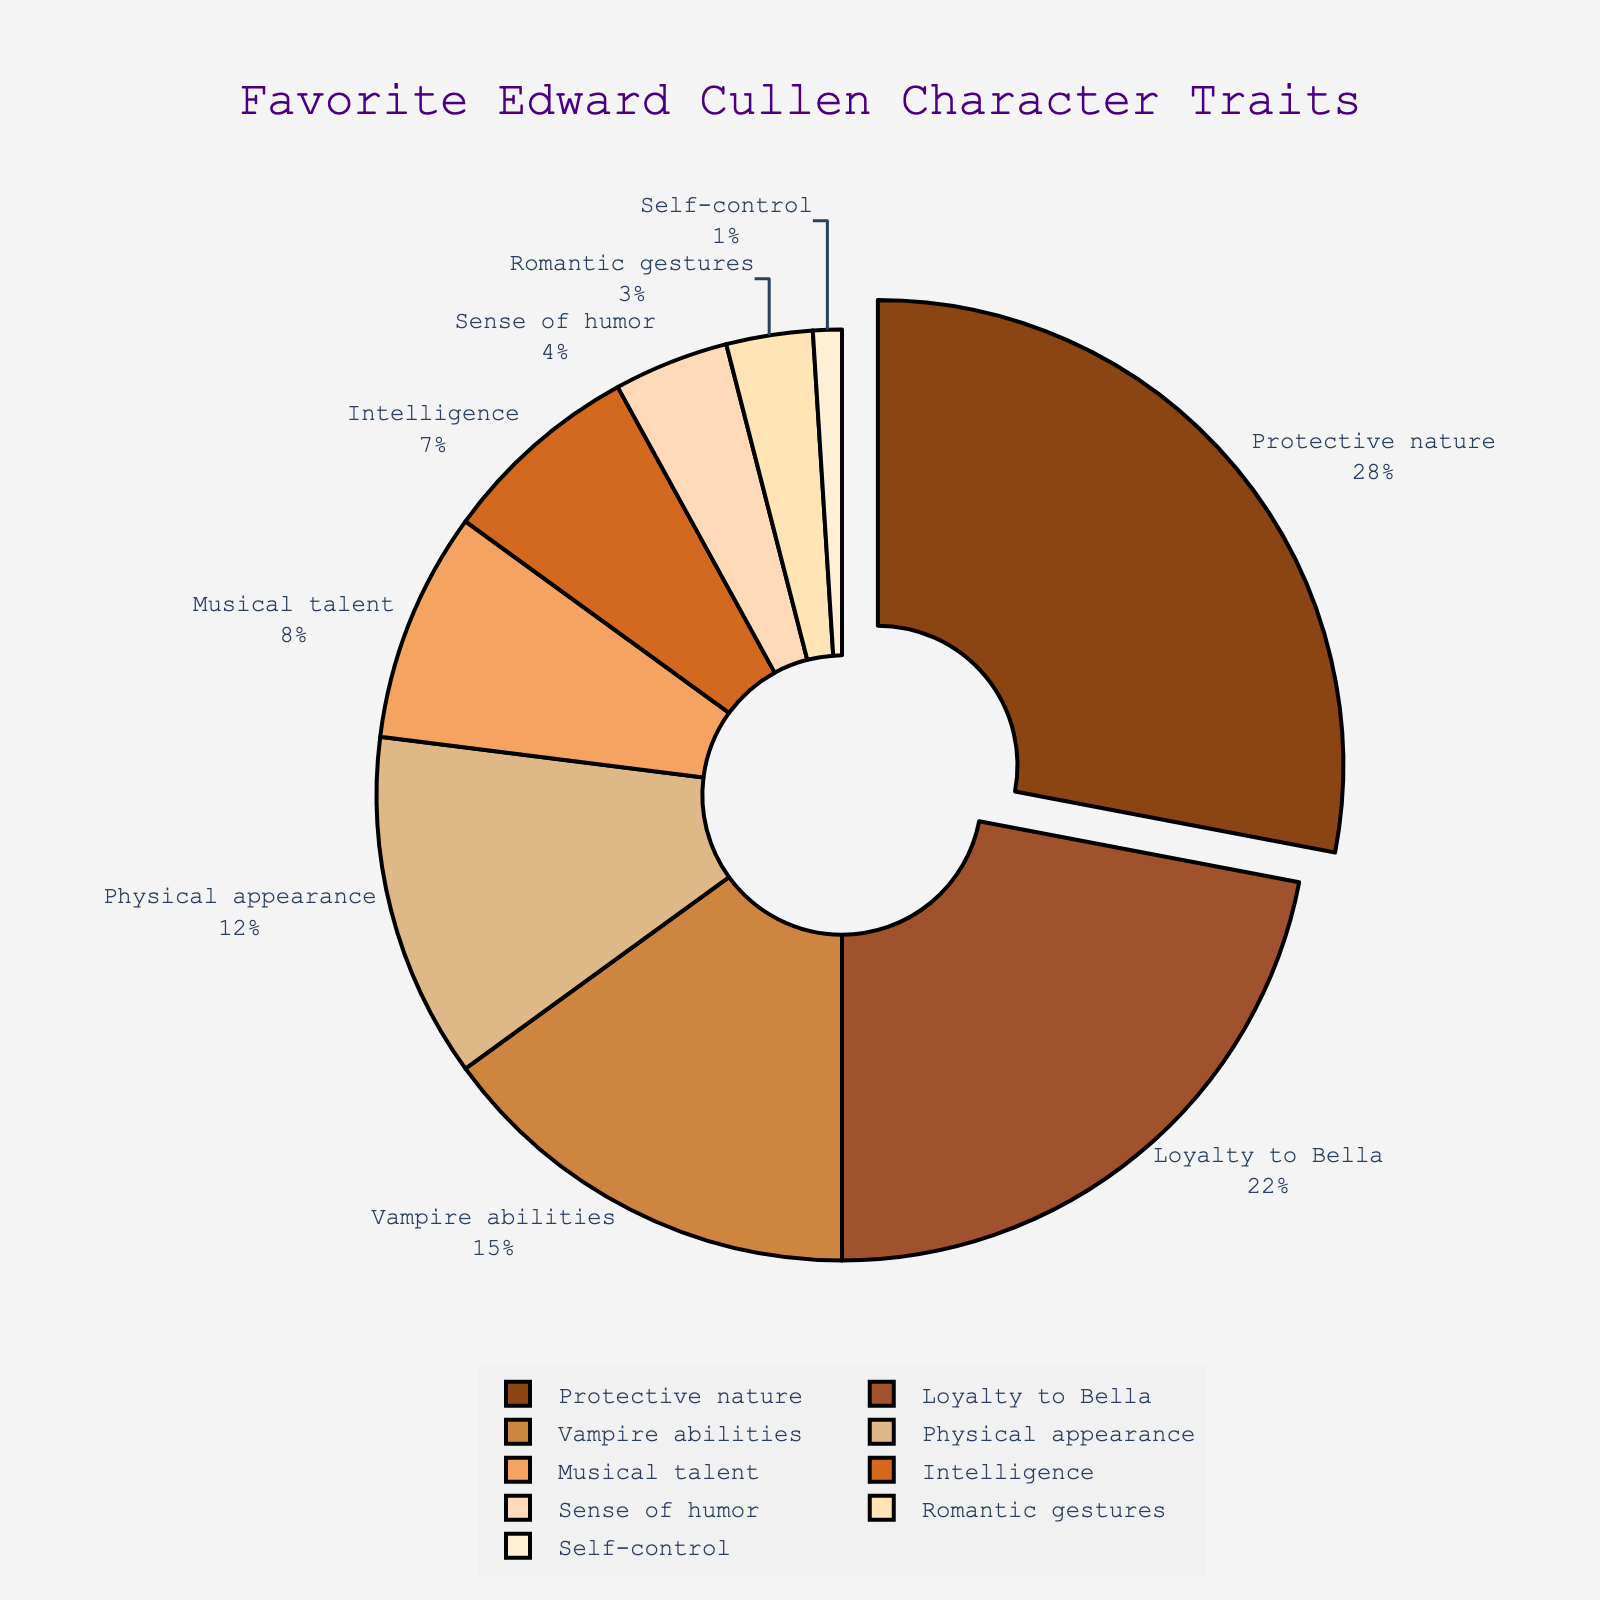Which trait is the least favorite among fans? To find the least favorite trait, look for the trait with the smallest percentage. From the data, the "Self-control" trait has the smallest percentage.
Answer: Self-control What percentage of fans voted for "Musical talent"? The chart directly shows the percentage of fans who voted for "Musical talent" as 8%.
Answer: 8% How much more popular is "Protective nature" compared to "Romantic gestures"? To determine how much more popular "Protective nature" is compared to "Romantic gestures", subtract the percentage for "Romantic gestures" (3%) from the percentage for "Protective nature" (28%).
Answer: 25% Compare the combined popularity of "Intelligence" and "Sense of humor" to "Loyalty to Bella". Which one is higher? Sum the percentages for "Intelligence" (7%) and "Sense of humor" (4%), which gives 11%. Compare this to "Loyalty to Bella", which has a percentage of 22%. "Loyalty to Bella" is higher.
Answer: Loyalty to Bella Which trait forms the largest segment in the pie chart? The largest segment in a pie chart corresponds to the highest percentage value. From the data, "Protective nature" has the highest percentage at 28%.
Answer: Protective nature How do the percentages for "Vampire abilities" and "Physical appearance" compare? "Vampire abilities" has a percentage of 15%, while "Physical appearance" has a percentage of 12%. Compare these two values to see that "Vampire abilities" is higher by 3%.
Answer: Vampire abilities is higher Calculate the total percentage of fans who voted for either "Protective nature", "Loyalty to Bella", or "Vampire abilities". Sum the percentages for these three traits: 28% (Protective nature) + 22% (Loyalty to Bella) + 15% (Vampire abilities) = 65%.
Answer: 65% What is the difference in popularity between the "Self-control" and the least popular of the top four traits? The least popular of the top four traits is "Physical appearance" with 12%. The difference between "Physical appearance" (12%) and "Self-control" (1%) is 12% - 1% = 11%.
Answer: 11% What color is used to represent "Musical talent"? By inspecting the colors associated with each segment, the color for "Musical talent" can be identified as a specific shade of brown.
Answer: Shade of brown What is the median percentage value of all the traits listed? To find the median, sort the percentage values in ascending order and find the middle value. Ordered percentages: 1, 3, 4, 7, 8, 12, 15, 22, 28. The middle value, or median, is 8.
Answer: 8 